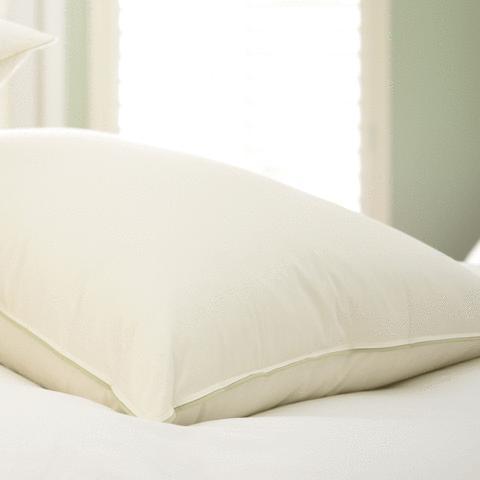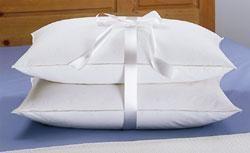The first image is the image on the left, the second image is the image on the right. Assess this claim about the two images: "There is only one pillow in one of the images.". Correct or not? Answer yes or no. Yes. The first image is the image on the left, the second image is the image on the right. For the images displayed, is the sentence "There are three pillows in the pair of images." factually correct? Answer yes or no. Yes. 